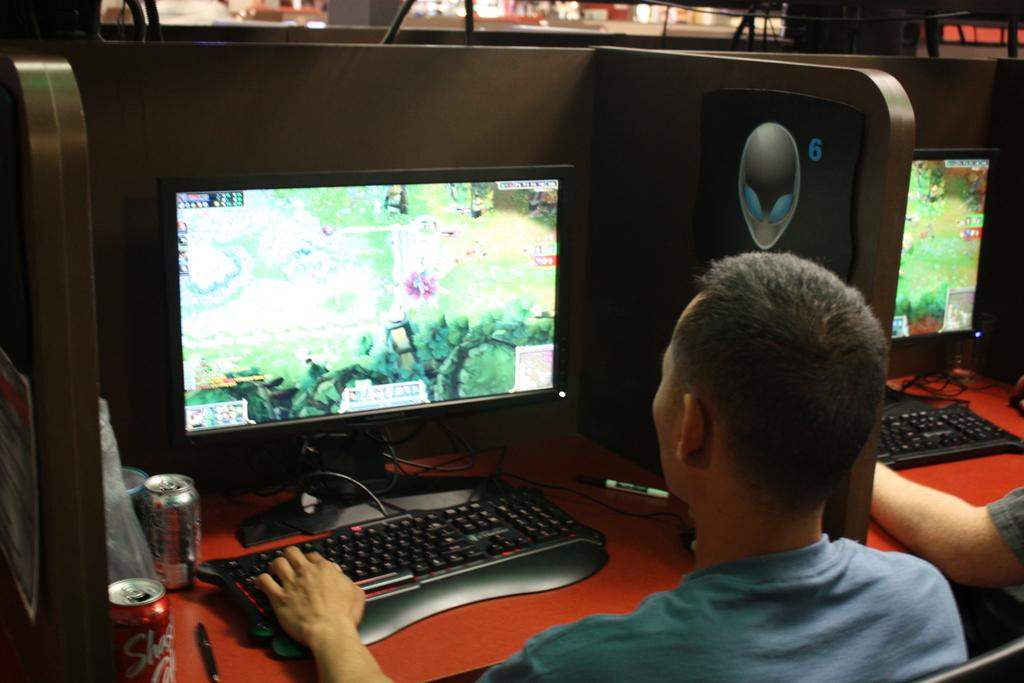What are the persons in the image doing? The persons seem to be playing a game. What objects are on the tables in front of the persons? The tables have computers, keyboards, and soft drink tins tins on them. What type of electronic devices are on the tables? The tables have computers on them. What might the persons be using to interact with the computers? The tables have keyboards on them, which the persons might be using to interact with the computers. Can you see any wounds on the persons playing the game in the image? There is no indication of any wounds on the persons in the image. What type of basin is visible in the image? There is no basin present in the image. 